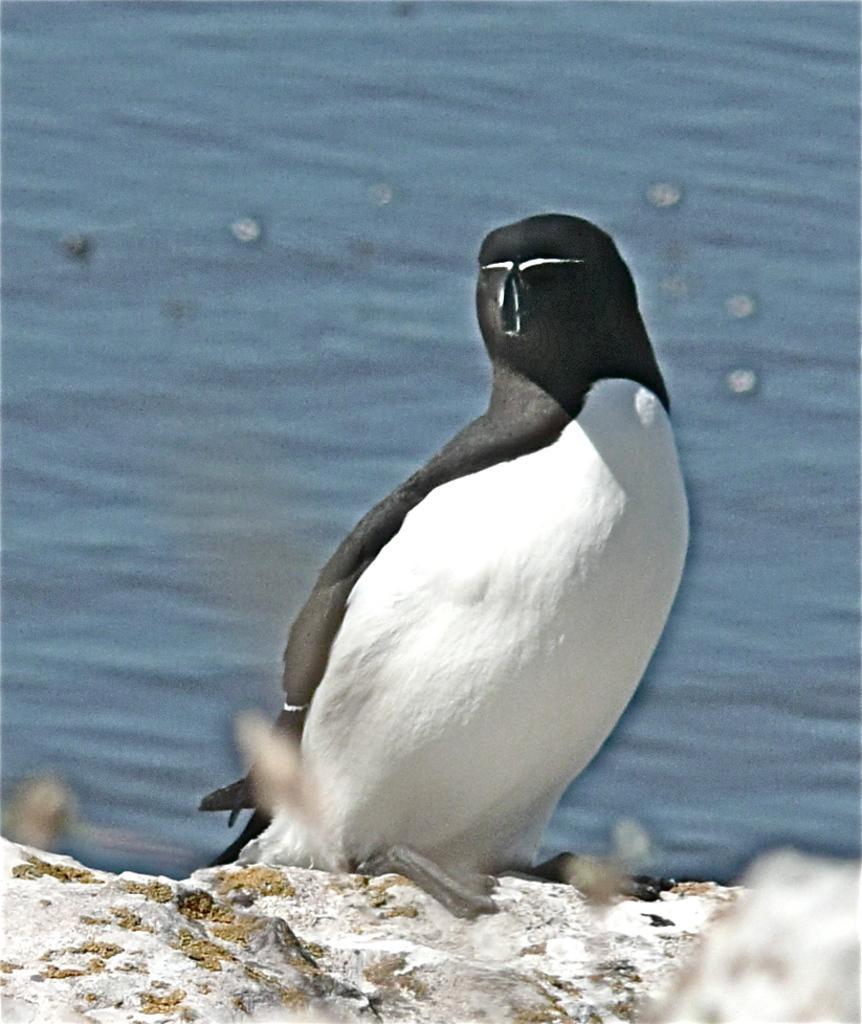Describe this image in one or two sentences. Background portion of the picture is blurred. We can see the water. In this picture we can see a penguin on the rock surface. 